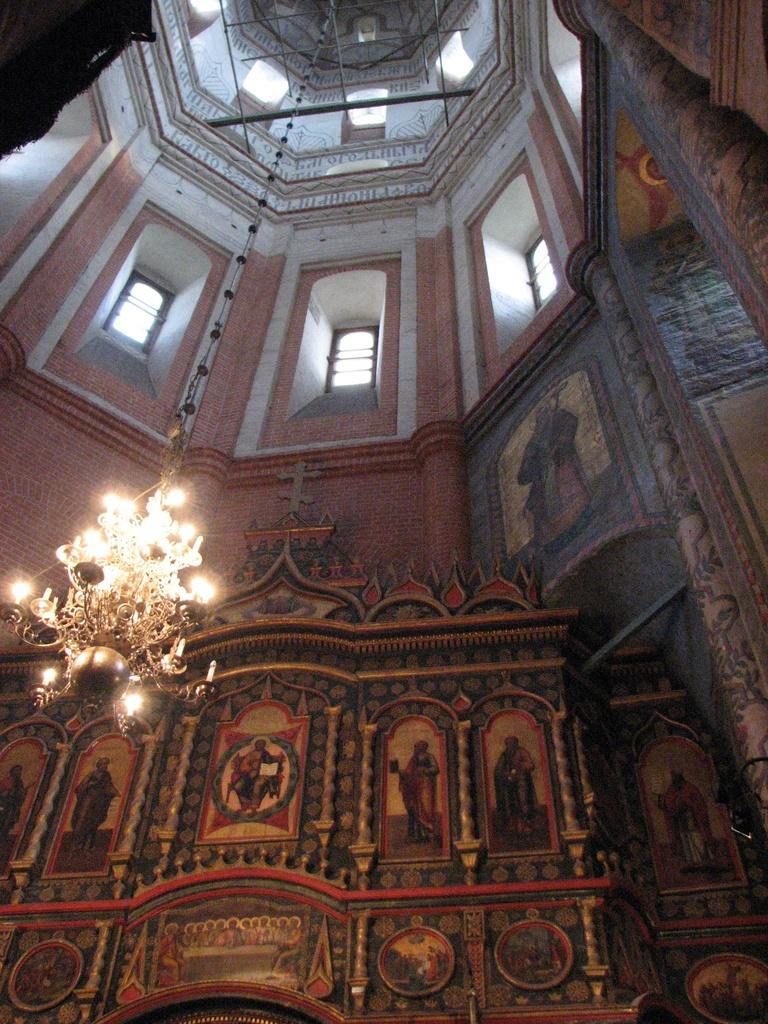Could you give a brief overview of what you see in this image? This image is clicked inside the building. In the front, we can see the arts on the wall. In the middle, there is a light hanged to the roof. 